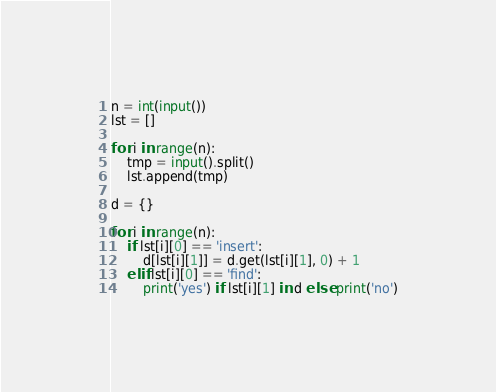Convert code to text. <code><loc_0><loc_0><loc_500><loc_500><_Python_>n = int(input())
lst = []

for i in range(n):
	tmp = input().split()
	lst.append(tmp)
	
d = {}

for i in range(n):
	if lst[i][0] == 'insert':
		d[lst[i][1]] = d.get(lst[i][1], 0) + 1
	elif lst[i][0] == 'find':
		print('yes') if lst[i][1] in d else print('no')
</code> 